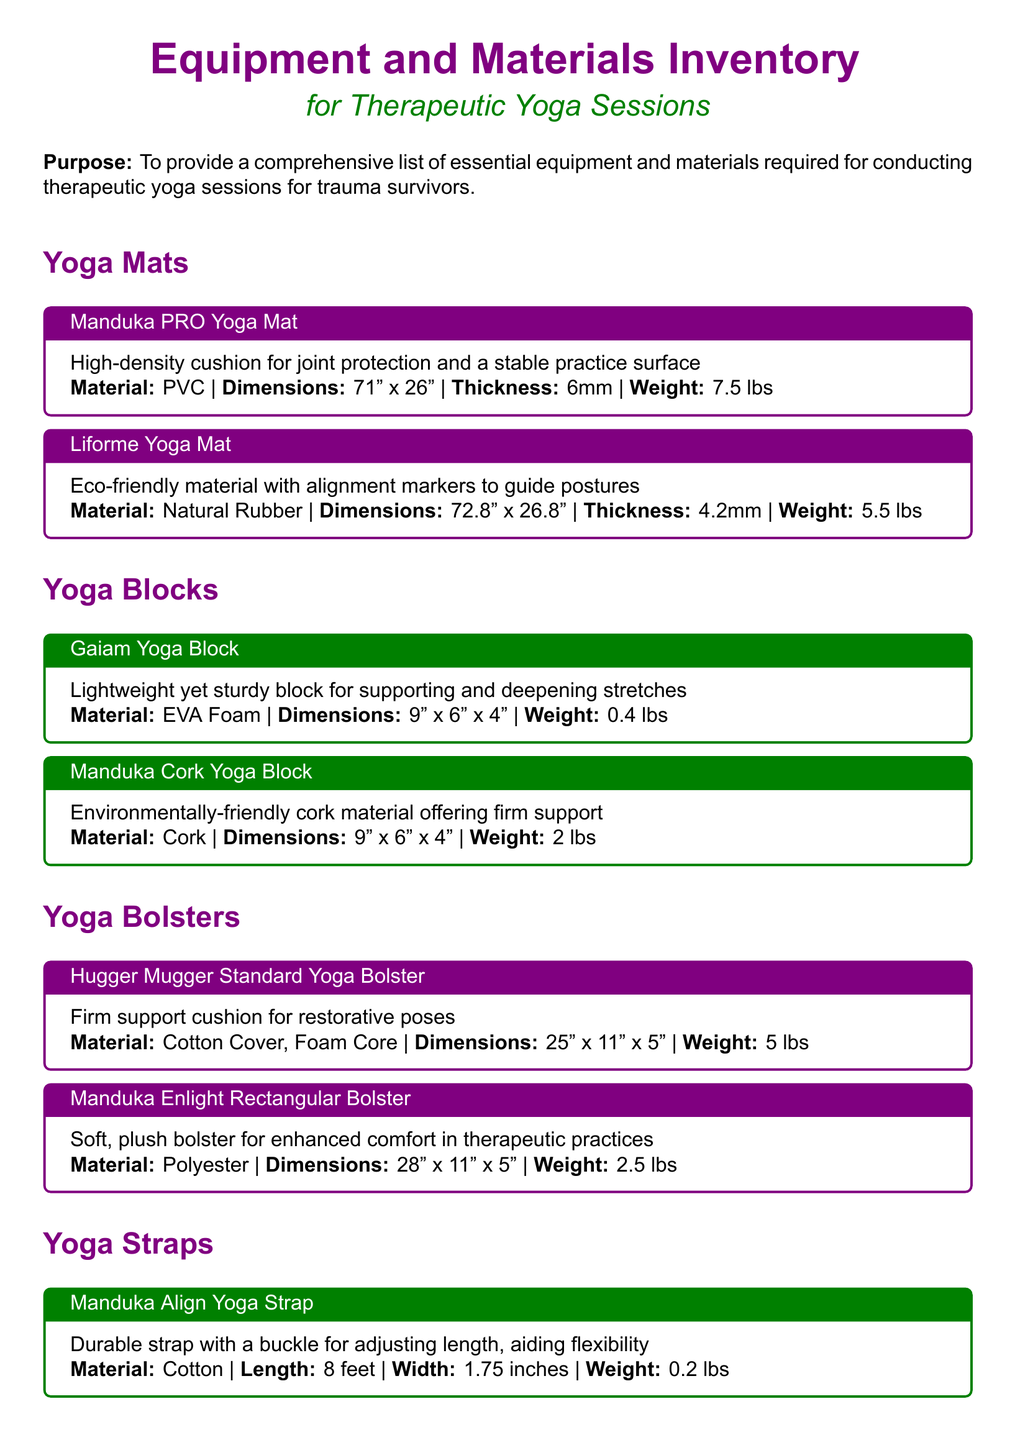What is the thickness of the Manduka PRO Yoga Mat? The thickness of the Manduka PRO Yoga Mat is specified in the document as 6mm.
Answer: 6mm What material is the Liforme Yoga Mat made from? The Liforme Yoga Mat is made from natural rubber, as mentioned in the document.
Answer: Natural Rubber What dimensions are provided for the Hugger Mugger Standard Yoga Bolster? The document lists the dimensions of the Hugger Mugger Standard Yoga Bolster as 25" x 11" x 5".
Answer: 25" x 11" x 5" How much does the Gaiam Yoga Block weigh? The weight of the Gaiam Yoga Block is indicated in the document as 0.4 lbs.
Answer: 0.4 lbs Which yoga strap has a length of 8 feet? The Manduka Align Yoga Strap is specified in the document as having a length of 8 feet.
Answer: Manduka Align Yoga Strap What type of fabric does the Eye Pillows have? The document describes the Eye Pillows as being made of silk, filled with flaxseed and lavender.
Answer: Silk How many types of yoga mats are listed? The document provides information about two types of yoga mats, the Manduka PRO and Liforme.
Answer: Two What is the purpose of the inventory list? The document states that the purpose is to provide a comprehensive list of essential equipment and materials for therapeutic yoga sessions for trauma survivors.
Answer: Comprehensive list Which item is used to enhance relaxation during savasana? The document mentions lavender-scented eye pillows as an item used to enhance relaxation during savasana.
Answer: Eye Pillows 